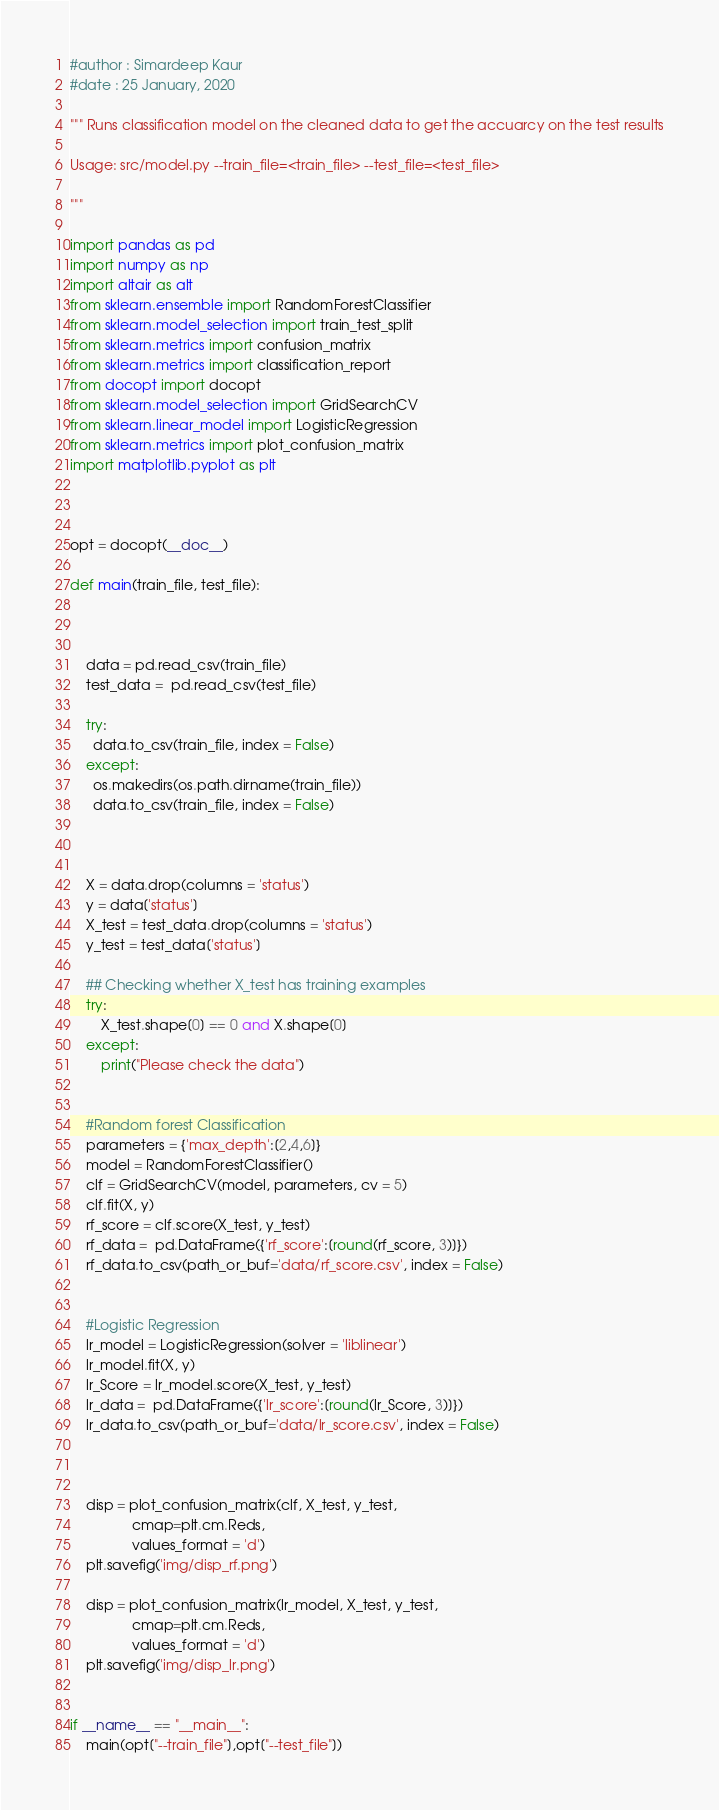<code> <loc_0><loc_0><loc_500><loc_500><_Python_>
#author : Simardeep Kaur
#date : 25 January, 2020

""" Runs classification model on the cleaned data to get the accuarcy on the test results

Usage: src/model.py --train_file=<train_file> --test_file=<test_file>

"""

import pandas as pd
import numpy as np
import altair as alt
from sklearn.ensemble import RandomForestClassifier
from sklearn.model_selection import train_test_split
from sklearn.metrics import confusion_matrix
from sklearn.metrics import classification_report
from docopt import docopt
from sklearn.model_selection import GridSearchCV
from sklearn.linear_model import LogisticRegression
from sklearn.metrics import plot_confusion_matrix
import matplotlib.pyplot as plt



opt = docopt(__doc__)

def main(train_file, test_file):



    data = pd.read_csv(train_file)
    test_data =  pd.read_csv(test_file)

    try:
      data.to_csv(train_file, index = False)
    except:
      os.makedirs(os.path.dirname(train_file))
      data.to_csv(train_file, index = False)



    X = data.drop(columns = 'status')
    y = data['status']
    X_test = test_data.drop(columns = 'status')
    y_test = test_data['status']

    ## Checking whether X_test has training examples
    try:
        X_test.shape[0] == 0 and X.shape[0]
    except:
        print("Please check the data")


    #Random forest Classification
    parameters = {'max_depth':[2,4,6]}
    model = RandomForestClassifier()
    clf = GridSearchCV(model, parameters, cv = 5)
    clf.fit(X, y)
    rf_score = clf.score(X_test, y_test)
    rf_data =  pd.DataFrame({'rf_score':[round(rf_score, 3)]})
    rf_data.to_csv(path_or_buf='data/rf_score.csv', index = False)


    #Logistic Regression
    lr_model = LogisticRegression(solver = 'liblinear')
    lr_model.fit(X, y)
    lr_Score = lr_model.score(X_test, y_test)
    lr_data =  pd.DataFrame({'lr_score':[round(lr_Score, 3)]})
    lr_data.to_csv(path_or_buf='data/lr_score.csv', index = False)



    disp = plot_confusion_matrix(clf, X_test, y_test,
                cmap=plt.cm.Reds,
                values_format = 'd')
    plt.savefig('img/disp_rf.png')

    disp = plot_confusion_matrix(lr_model, X_test, y_test,
                cmap=plt.cm.Reds,
                values_format = 'd')
    plt.savefig('img/disp_lr.png')


if __name__ == "__main__":
    main(opt["--train_file"],opt["--test_file"])
</code> 